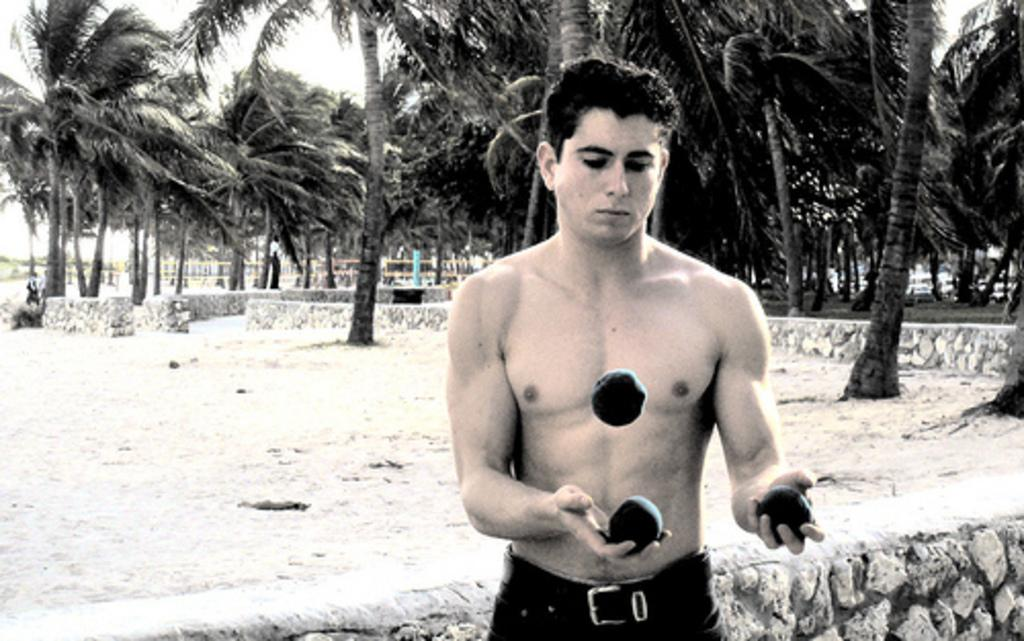What is the main subject of the image? There is a man standing in the image. What is the man wearing? The man is wearing trousers. What is the man doing in the image? The man is playing with a circular object. What type of terrain is visible in the image? There is sand visible in the image. What type of vegetation is present in the image? There are trees in the image. What is visible in the background of the image? The sky is visible in the image. What type of bird can be seen flying in the image? There is no bird visible in the image. What color is the curtain hanging in the background of the image? There is no curtain present in the image. 